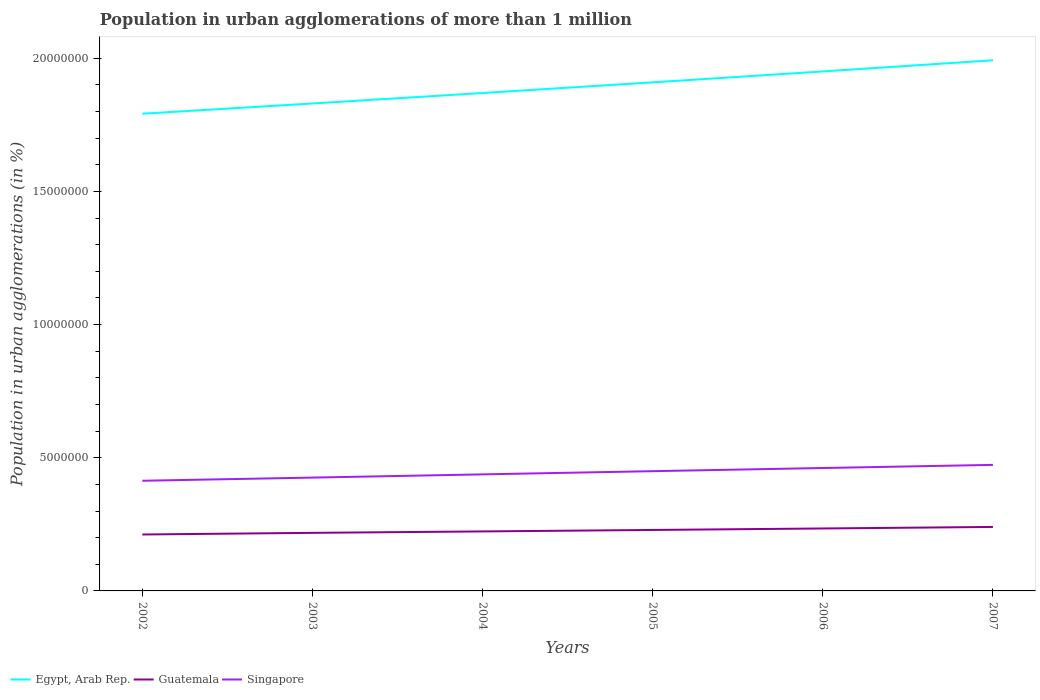How many different coloured lines are there?
Your response must be concise. 3. Is the number of lines equal to the number of legend labels?
Your response must be concise. Yes. Across all years, what is the maximum population in urban agglomerations in Singapore?
Your answer should be compact. 4.14e+06. In which year was the population in urban agglomerations in Guatemala maximum?
Your answer should be very brief. 2002. What is the total population in urban agglomerations in Singapore in the graph?
Keep it short and to the point. -2.39e+05. What is the difference between the highest and the second highest population in urban agglomerations in Egypt, Arab Rep.?
Keep it short and to the point. 2.01e+06. What is the difference between the highest and the lowest population in urban agglomerations in Singapore?
Offer a terse response. 3. Is the population in urban agglomerations in Egypt, Arab Rep. strictly greater than the population in urban agglomerations in Guatemala over the years?
Keep it short and to the point. No. How many lines are there?
Offer a terse response. 3. How many years are there in the graph?
Your answer should be compact. 6. What is the difference between two consecutive major ticks on the Y-axis?
Your answer should be compact. 5.00e+06. Are the values on the major ticks of Y-axis written in scientific E-notation?
Offer a very short reply. No. Does the graph contain grids?
Ensure brevity in your answer.  No. Where does the legend appear in the graph?
Offer a very short reply. Bottom left. What is the title of the graph?
Offer a terse response. Population in urban agglomerations of more than 1 million. What is the label or title of the X-axis?
Give a very brief answer. Years. What is the label or title of the Y-axis?
Provide a short and direct response. Population in urban agglomerations (in %). What is the Population in urban agglomerations (in %) in Egypt, Arab Rep. in 2002?
Your answer should be very brief. 1.79e+07. What is the Population in urban agglomerations (in %) of Guatemala in 2002?
Your response must be concise. 2.12e+06. What is the Population in urban agglomerations (in %) in Singapore in 2002?
Your answer should be compact. 4.14e+06. What is the Population in urban agglomerations (in %) of Egypt, Arab Rep. in 2003?
Keep it short and to the point. 1.83e+07. What is the Population in urban agglomerations (in %) of Guatemala in 2003?
Offer a terse response. 2.18e+06. What is the Population in urban agglomerations (in %) of Singapore in 2003?
Your answer should be very brief. 4.25e+06. What is the Population in urban agglomerations (in %) in Egypt, Arab Rep. in 2004?
Make the answer very short. 1.87e+07. What is the Population in urban agglomerations (in %) of Guatemala in 2004?
Make the answer very short. 2.23e+06. What is the Population in urban agglomerations (in %) in Singapore in 2004?
Ensure brevity in your answer.  4.38e+06. What is the Population in urban agglomerations (in %) of Egypt, Arab Rep. in 2005?
Make the answer very short. 1.91e+07. What is the Population in urban agglomerations (in %) of Guatemala in 2005?
Offer a terse response. 2.29e+06. What is the Population in urban agglomerations (in %) in Singapore in 2005?
Make the answer very short. 4.50e+06. What is the Population in urban agglomerations (in %) of Egypt, Arab Rep. in 2006?
Provide a short and direct response. 1.95e+07. What is the Population in urban agglomerations (in %) in Guatemala in 2006?
Make the answer very short. 2.34e+06. What is the Population in urban agglomerations (in %) of Singapore in 2006?
Offer a terse response. 4.61e+06. What is the Population in urban agglomerations (in %) of Egypt, Arab Rep. in 2007?
Provide a succinct answer. 1.99e+07. What is the Population in urban agglomerations (in %) of Guatemala in 2007?
Offer a very short reply. 2.40e+06. What is the Population in urban agglomerations (in %) in Singapore in 2007?
Provide a short and direct response. 4.73e+06. Across all years, what is the maximum Population in urban agglomerations (in %) of Egypt, Arab Rep.?
Ensure brevity in your answer.  1.99e+07. Across all years, what is the maximum Population in urban agglomerations (in %) of Guatemala?
Ensure brevity in your answer.  2.40e+06. Across all years, what is the maximum Population in urban agglomerations (in %) of Singapore?
Offer a terse response. 4.73e+06. Across all years, what is the minimum Population in urban agglomerations (in %) in Egypt, Arab Rep.?
Provide a short and direct response. 1.79e+07. Across all years, what is the minimum Population in urban agglomerations (in %) in Guatemala?
Make the answer very short. 2.12e+06. Across all years, what is the minimum Population in urban agglomerations (in %) in Singapore?
Provide a short and direct response. 4.14e+06. What is the total Population in urban agglomerations (in %) of Egypt, Arab Rep. in the graph?
Give a very brief answer. 1.13e+08. What is the total Population in urban agglomerations (in %) of Guatemala in the graph?
Your answer should be very brief. 1.36e+07. What is the total Population in urban agglomerations (in %) in Singapore in the graph?
Ensure brevity in your answer.  2.66e+07. What is the difference between the Population in urban agglomerations (in %) of Egypt, Arab Rep. in 2002 and that in 2003?
Give a very brief answer. -3.84e+05. What is the difference between the Population in urban agglomerations (in %) in Guatemala in 2002 and that in 2003?
Give a very brief answer. -6.19e+04. What is the difference between the Population in urban agglomerations (in %) of Singapore in 2002 and that in 2003?
Your answer should be compact. -1.19e+05. What is the difference between the Population in urban agglomerations (in %) in Egypt, Arab Rep. in 2002 and that in 2004?
Your answer should be very brief. -7.78e+05. What is the difference between the Population in urban agglomerations (in %) of Guatemala in 2002 and that in 2004?
Offer a very short reply. -1.15e+05. What is the difference between the Population in urban agglomerations (in %) of Singapore in 2002 and that in 2004?
Offer a very short reply. -2.39e+05. What is the difference between the Population in urban agglomerations (in %) in Egypt, Arab Rep. in 2002 and that in 2005?
Ensure brevity in your answer.  -1.18e+06. What is the difference between the Population in urban agglomerations (in %) in Guatemala in 2002 and that in 2005?
Your response must be concise. -1.70e+05. What is the difference between the Population in urban agglomerations (in %) in Singapore in 2002 and that in 2005?
Offer a terse response. -3.59e+05. What is the difference between the Population in urban agglomerations (in %) of Egypt, Arab Rep. in 2002 and that in 2006?
Give a very brief answer. -1.59e+06. What is the difference between the Population in urban agglomerations (in %) of Guatemala in 2002 and that in 2006?
Keep it short and to the point. -2.26e+05. What is the difference between the Population in urban agglomerations (in %) of Singapore in 2002 and that in 2006?
Offer a very short reply. -4.78e+05. What is the difference between the Population in urban agglomerations (in %) of Egypt, Arab Rep. in 2002 and that in 2007?
Offer a terse response. -2.01e+06. What is the difference between the Population in urban agglomerations (in %) of Guatemala in 2002 and that in 2007?
Your response must be concise. -2.84e+05. What is the difference between the Population in urban agglomerations (in %) in Singapore in 2002 and that in 2007?
Keep it short and to the point. -5.96e+05. What is the difference between the Population in urban agglomerations (in %) in Egypt, Arab Rep. in 2003 and that in 2004?
Keep it short and to the point. -3.93e+05. What is the difference between the Population in urban agglomerations (in %) in Guatemala in 2003 and that in 2004?
Ensure brevity in your answer.  -5.36e+04. What is the difference between the Population in urban agglomerations (in %) of Singapore in 2003 and that in 2004?
Your answer should be compact. -1.21e+05. What is the difference between the Population in urban agglomerations (in %) in Egypt, Arab Rep. in 2003 and that in 2005?
Keep it short and to the point. -7.94e+05. What is the difference between the Population in urban agglomerations (in %) in Guatemala in 2003 and that in 2005?
Your answer should be very brief. -1.08e+05. What is the difference between the Population in urban agglomerations (in %) in Singapore in 2003 and that in 2005?
Ensure brevity in your answer.  -2.41e+05. What is the difference between the Population in urban agglomerations (in %) in Egypt, Arab Rep. in 2003 and that in 2006?
Provide a succinct answer. -1.20e+06. What is the difference between the Population in urban agglomerations (in %) in Guatemala in 2003 and that in 2006?
Your answer should be compact. -1.64e+05. What is the difference between the Population in urban agglomerations (in %) in Singapore in 2003 and that in 2006?
Give a very brief answer. -3.60e+05. What is the difference between the Population in urban agglomerations (in %) of Egypt, Arab Rep. in 2003 and that in 2007?
Your answer should be very brief. -1.62e+06. What is the difference between the Population in urban agglomerations (in %) in Guatemala in 2003 and that in 2007?
Provide a succinct answer. -2.22e+05. What is the difference between the Population in urban agglomerations (in %) in Singapore in 2003 and that in 2007?
Offer a terse response. -4.77e+05. What is the difference between the Population in urban agglomerations (in %) of Egypt, Arab Rep. in 2004 and that in 2005?
Your response must be concise. -4.01e+05. What is the difference between the Population in urban agglomerations (in %) in Guatemala in 2004 and that in 2005?
Your answer should be very brief. -5.47e+04. What is the difference between the Population in urban agglomerations (in %) in Singapore in 2004 and that in 2005?
Provide a short and direct response. -1.20e+05. What is the difference between the Population in urban agglomerations (in %) of Egypt, Arab Rep. in 2004 and that in 2006?
Your response must be concise. -8.10e+05. What is the difference between the Population in urban agglomerations (in %) in Guatemala in 2004 and that in 2006?
Your response must be concise. -1.11e+05. What is the difference between the Population in urban agglomerations (in %) in Singapore in 2004 and that in 2006?
Offer a terse response. -2.39e+05. What is the difference between the Population in urban agglomerations (in %) in Egypt, Arab Rep. in 2004 and that in 2007?
Offer a very short reply. -1.23e+06. What is the difference between the Population in urban agglomerations (in %) in Guatemala in 2004 and that in 2007?
Your response must be concise. -1.68e+05. What is the difference between the Population in urban agglomerations (in %) of Singapore in 2004 and that in 2007?
Your response must be concise. -3.57e+05. What is the difference between the Population in urban agglomerations (in %) of Egypt, Arab Rep. in 2005 and that in 2006?
Offer a terse response. -4.10e+05. What is the difference between the Population in urban agglomerations (in %) of Guatemala in 2005 and that in 2006?
Give a very brief answer. -5.62e+04. What is the difference between the Population in urban agglomerations (in %) in Singapore in 2005 and that in 2006?
Make the answer very short. -1.19e+05. What is the difference between the Population in urban agglomerations (in %) of Egypt, Arab Rep. in 2005 and that in 2007?
Offer a very short reply. -8.28e+05. What is the difference between the Population in urban agglomerations (in %) in Guatemala in 2005 and that in 2007?
Make the answer very short. -1.14e+05. What is the difference between the Population in urban agglomerations (in %) of Singapore in 2005 and that in 2007?
Offer a terse response. -2.37e+05. What is the difference between the Population in urban agglomerations (in %) of Egypt, Arab Rep. in 2006 and that in 2007?
Provide a short and direct response. -4.18e+05. What is the difference between the Population in urban agglomerations (in %) in Guatemala in 2006 and that in 2007?
Provide a succinct answer. -5.75e+04. What is the difference between the Population in urban agglomerations (in %) in Singapore in 2006 and that in 2007?
Keep it short and to the point. -1.18e+05. What is the difference between the Population in urban agglomerations (in %) of Egypt, Arab Rep. in 2002 and the Population in urban agglomerations (in %) of Guatemala in 2003?
Give a very brief answer. 1.57e+07. What is the difference between the Population in urban agglomerations (in %) in Egypt, Arab Rep. in 2002 and the Population in urban agglomerations (in %) in Singapore in 2003?
Offer a very short reply. 1.37e+07. What is the difference between the Population in urban agglomerations (in %) of Guatemala in 2002 and the Population in urban agglomerations (in %) of Singapore in 2003?
Provide a short and direct response. -2.14e+06. What is the difference between the Population in urban agglomerations (in %) in Egypt, Arab Rep. in 2002 and the Population in urban agglomerations (in %) in Guatemala in 2004?
Keep it short and to the point. 1.57e+07. What is the difference between the Population in urban agglomerations (in %) in Egypt, Arab Rep. in 2002 and the Population in urban agglomerations (in %) in Singapore in 2004?
Provide a succinct answer. 1.35e+07. What is the difference between the Population in urban agglomerations (in %) in Guatemala in 2002 and the Population in urban agglomerations (in %) in Singapore in 2004?
Offer a terse response. -2.26e+06. What is the difference between the Population in urban agglomerations (in %) in Egypt, Arab Rep. in 2002 and the Population in urban agglomerations (in %) in Guatemala in 2005?
Your answer should be very brief. 1.56e+07. What is the difference between the Population in urban agglomerations (in %) in Egypt, Arab Rep. in 2002 and the Population in urban agglomerations (in %) in Singapore in 2005?
Ensure brevity in your answer.  1.34e+07. What is the difference between the Population in urban agglomerations (in %) of Guatemala in 2002 and the Population in urban agglomerations (in %) of Singapore in 2005?
Keep it short and to the point. -2.38e+06. What is the difference between the Population in urban agglomerations (in %) of Egypt, Arab Rep. in 2002 and the Population in urban agglomerations (in %) of Guatemala in 2006?
Offer a terse response. 1.56e+07. What is the difference between the Population in urban agglomerations (in %) in Egypt, Arab Rep. in 2002 and the Population in urban agglomerations (in %) in Singapore in 2006?
Provide a succinct answer. 1.33e+07. What is the difference between the Population in urban agglomerations (in %) in Guatemala in 2002 and the Population in urban agglomerations (in %) in Singapore in 2006?
Provide a succinct answer. -2.50e+06. What is the difference between the Population in urban agglomerations (in %) in Egypt, Arab Rep. in 2002 and the Population in urban agglomerations (in %) in Guatemala in 2007?
Provide a succinct answer. 1.55e+07. What is the difference between the Population in urban agglomerations (in %) of Egypt, Arab Rep. in 2002 and the Population in urban agglomerations (in %) of Singapore in 2007?
Offer a very short reply. 1.32e+07. What is the difference between the Population in urban agglomerations (in %) of Guatemala in 2002 and the Population in urban agglomerations (in %) of Singapore in 2007?
Offer a terse response. -2.61e+06. What is the difference between the Population in urban agglomerations (in %) in Egypt, Arab Rep. in 2003 and the Population in urban agglomerations (in %) in Guatemala in 2004?
Your answer should be compact. 1.61e+07. What is the difference between the Population in urban agglomerations (in %) in Egypt, Arab Rep. in 2003 and the Population in urban agglomerations (in %) in Singapore in 2004?
Ensure brevity in your answer.  1.39e+07. What is the difference between the Population in urban agglomerations (in %) in Guatemala in 2003 and the Population in urban agglomerations (in %) in Singapore in 2004?
Provide a short and direct response. -2.19e+06. What is the difference between the Population in urban agglomerations (in %) in Egypt, Arab Rep. in 2003 and the Population in urban agglomerations (in %) in Guatemala in 2005?
Keep it short and to the point. 1.60e+07. What is the difference between the Population in urban agglomerations (in %) of Egypt, Arab Rep. in 2003 and the Population in urban agglomerations (in %) of Singapore in 2005?
Keep it short and to the point. 1.38e+07. What is the difference between the Population in urban agglomerations (in %) in Guatemala in 2003 and the Population in urban agglomerations (in %) in Singapore in 2005?
Your answer should be very brief. -2.32e+06. What is the difference between the Population in urban agglomerations (in %) of Egypt, Arab Rep. in 2003 and the Population in urban agglomerations (in %) of Guatemala in 2006?
Provide a short and direct response. 1.60e+07. What is the difference between the Population in urban agglomerations (in %) in Egypt, Arab Rep. in 2003 and the Population in urban agglomerations (in %) in Singapore in 2006?
Your answer should be very brief. 1.37e+07. What is the difference between the Population in urban agglomerations (in %) of Guatemala in 2003 and the Population in urban agglomerations (in %) of Singapore in 2006?
Provide a short and direct response. -2.43e+06. What is the difference between the Population in urban agglomerations (in %) in Egypt, Arab Rep. in 2003 and the Population in urban agglomerations (in %) in Guatemala in 2007?
Provide a succinct answer. 1.59e+07. What is the difference between the Population in urban agglomerations (in %) in Egypt, Arab Rep. in 2003 and the Population in urban agglomerations (in %) in Singapore in 2007?
Offer a very short reply. 1.36e+07. What is the difference between the Population in urban agglomerations (in %) in Guatemala in 2003 and the Population in urban agglomerations (in %) in Singapore in 2007?
Give a very brief answer. -2.55e+06. What is the difference between the Population in urban agglomerations (in %) in Egypt, Arab Rep. in 2004 and the Population in urban agglomerations (in %) in Guatemala in 2005?
Offer a very short reply. 1.64e+07. What is the difference between the Population in urban agglomerations (in %) in Egypt, Arab Rep. in 2004 and the Population in urban agglomerations (in %) in Singapore in 2005?
Ensure brevity in your answer.  1.42e+07. What is the difference between the Population in urban agglomerations (in %) of Guatemala in 2004 and the Population in urban agglomerations (in %) of Singapore in 2005?
Your answer should be very brief. -2.26e+06. What is the difference between the Population in urban agglomerations (in %) in Egypt, Arab Rep. in 2004 and the Population in urban agglomerations (in %) in Guatemala in 2006?
Offer a terse response. 1.63e+07. What is the difference between the Population in urban agglomerations (in %) of Egypt, Arab Rep. in 2004 and the Population in urban agglomerations (in %) of Singapore in 2006?
Ensure brevity in your answer.  1.41e+07. What is the difference between the Population in urban agglomerations (in %) in Guatemala in 2004 and the Population in urban agglomerations (in %) in Singapore in 2006?
Keep it short and to the point. -2.38e+06. What is the difference between the Population in urban agglomerations (in %) in Egypt, Arab Rep. in 2004 and the Population in urban agglomerations (in %) in Guatemala in 2007?
Your response must be concise. 1.63e+07. What is the difference between the Population in urban agglomerations (in %) in Egypt, Arab Rep. in 2004 and the Population in urban agglomerations (in %) in Singapore in 2007?
Offer a very short reply. 1.40e+07. What is the difference between the Population in urban agglomerations (in %) of Guatemala in 2004 and the Population in urban agglomerations (in %) of Singapore in 2007?
Offer a very short reply. -2.50e+06. What is the difference between the Population in urban agglomerations (in %) in Egypt, Arab Rep. in 2005 and the Population in urban agglomerations (in %) in Guatemala in 2006?
Your response must be concise. 1.67e+07. What is the difference between the Population in urban agglomerations (in %) in Egypt, Arab Rep. in 2005 and the Population in urban agglomerations (in %) in Singapore in 2006?
Keep it short and to the point. 1.45e+07. What is the difference between the Population in urban agglomerations (in %) of Guatemala in 2005 and the Population in urban agglomerations (in %) of Singapore in 2006?
Give a very brief answer. -2.33e+06. What is the difference between the Population in urban agglomerations (in %) of Egypt, Arab Rep. in 2005 and the Population in urban agglomerations (in %) of Guatemala in 2007?
Provide a succinct answer. 1.67e+07. What is the difference between the Population in urban agglomerations (in %) of Egypt, Arab Rep. in 2005 and the Population in urban agglomerations (in %) of Singapore in 2007?
Offer a very short reply. 1.44e+07. What is the difference between the Population in urban agglomerations (in %) of Guatemala in 2005 and the Population in urban agglomerations (in %) of Singapore in 2007?
Your answer should be compact. -2.44e+06. What is the difference between the Population in urban agglomerations (in %) in Egypt, Arab Rep. in 2006 and the Population in urban agglomerations (in %) in Guatemala in 2007?
Your answer should be compact. 1.71e+07. What is the difference between the Population in urban agglomerations (in %) in Egypt, Arab Rep. in 2006 and the Population in urban agglomerations (in %) in Singapore in 2007?
Keep it short and to the point. 1.48e+07. What is the difference between the Population in urban agglomerations (in %) of Guatemala in 2006 and the Population in urban agglomerations (in %) of Singapore in 2007?
Keep it short and to the point. -2.39e+06. What is the average Population in urban agglomerations (in %) of Egypt, Arab Rep. per year?
Make the answer very short. 1.89e+07. What is the average Population in urban agglomerations (in %) in Guatemala per year?
Make the answer very short. 2.26e+06. What is the average Population in urban agglomerations (in %) in Singapore per year?
Provide a short and direct response. 4.43e+06. In the year 2002, what is the difference between the Population in urban agglomerations (in %) in Egypt, Arab Rep. and Population in urban agglomerations (in %) in Guatemala?
Provide a short and direct response. 1.58e+07. In the year 2002, what is the difference between the Population in urban agglomerations (in %) in Egypt, Arab Rep. and Population in urban agglomerations (in %) in Singapore?
Offer a terse response. 1.38e+07. In the year 2002, what is the difference between the Population in urban agglomerations (in %) of Guatemala and Population in urban agglomerations (in %) of Singapore?
Make the answer very short. -2.02e+06. In the year 2003, what is the difference between the Population in urban agglomerations (in %) of Egypt, Arab Rep. and Population in urban agglomerations (in %) of Guatemala?
Keep it short and to the point. 1.61e+07. In the year 2003, what is the difference between the Population in urban agglomerations (in %) in Egypt, Arab Rep. and Population in urban agglomerations (in %) in Singapore?
Offer a very short reply. 1.40e+07. In the year 2003, what is the difference between the Population in urban agglomerations (in %) of Guatemala and Population in urban agglomerations (in %) of Singapore?
Your response must be concise. -2.07e+06. In the year 2004, what is the difference between the Population in urban agglomerations (in %) in Egypt, Arab Rep. and Population in urban agglomerations (in %) in Guatemala?
Provide a succinct answer. 1.65e+07. In the year 2004, what is the difference between the Population in urban agglomerations (in %) in Egypt, Arab Rep. and Population in urban agglomerations (in %) in Singapore?
Provide a succinct answer. 1.43e+07. In the year 2004, what is the difference between the Population in urban agglomerations (in %) in Guatemala and Population in urban agglomerations (in %) in Singapore?
Provide a short and direct response. -2.14e+06. In the year 2005, what is the difference between the Population in urban agglomerations (in %) of Egypt, Arab Rep. and Population in urban agglomerations (in %) of Guatemala?
Provide a succinct answer. 1.68e+07. In the year 2005, what is the difference between the Population in urban agglomerations (in %) in Egypt, Arab Rep. and Population in urban agglomerations (in %) in Singapore?
Provide a succinct answer. 1.46e+07. In the year 2005, what is the difference between the Population in urban agglomerations (in %) of Guatemala and Population in urban agglomerations (in %) of Singapore?
Provide a short and direct response. -2.21e+06. In the year 2006, what is the difference between the Population in urban agglomerations (in %) of Egypt, Arab Rep. and Population in urban agglomerations (in %) of Guatemala?
Offer a very short reply. 1.72e+07. In the year 2006, what is the difference between the Population in urban agglomerations (in %) of Egypt, Arab Rep. and Population in urban agglomerations (in %) of Singapore?
Offer a terse response. 1.49e+07. In the year 2006, what is the difference between the Population in urban agglomerations (in %) in Guatemala and Population in urban agglomerations (in %) in Singapore?
Keep it short and to the point. -2.27e+06. In the year 2007, what is the difference between the Population in urban agglomerations (in %) of Egypt, Arab Rep. and Population in urban agglomerations (in %) of Guatemala?
Your response must be concise. 1.75e+07. In the year 2007, what is the difference between the Population in urban agglomerations (in %) of Egypt, Arab Rep. and Population in urban agglomerations (in %) of Singapore?
Offer a very short reply. 1.52e+07. In the year 2007, what is the difference between the Population in urban agglomerations (in %) in Guatemala and Population in urban agglomerations (in %) in Singapore?
Provide a short and direct response. -2.33e+06. What is the ratio of the Population in urban agglomerations (in %) in Egypt, Arab Rep. in 2002 to that in 2003?
Provide a succinct answer. 0.98. What is the ratio of the Population in urban agglomerations (in %) of Guatemala in 2002 to that in 2003?
Offer a terse response. 0.97. What is the ratio of the Population in urban agglomerations (in %) of Singapore in 2002 to that in 2003?
Provide a short and direct response. 0.97. What is the ratio of the Population in urban agglomerations (in %) in Egypt, Arab Rep. in 2002 to that in 2004?
Provide a short and direct response. 0.96. What is the ratio of the Population in urban agglomerations (in %) of Guatemala in 2002 to that in 2004?
Keep it short and to the point. 0.95. What is the ratio of the Population in urban agglomerations (in %) of Singapore in 2002 to that in 2004?
Keep it short and to the point. 0.95. What is the ratio of the Population in urban agglomerations (in %) in Egypt, Arab Rep. in 2002 to that in 2005?
Offer a very short reply. 0.94. What is the ratio of the Population in urban agglomerations (in %) of Guatemala in 2002 to that in 2005?
Your answer should be compact. 0.93. What is the ratio of the Population in urban agglomerations (in %) in Singapore in 2002 to that in 2005?
Offer a terse response. 0.92. What is the ratio of the Population in urban agglomerations (in %) of Egypt, Arab Rep. in 2002 to that in 2006?
Give a very brief answer. 0.92. What is the ratio of the Population in urban agglomerations (in %) of Guatemala in 2002 to that in 2006?
Provide a succinct answer. 0.9. What is the ratio of the Population in urban agglomerations (in %) of Singapore in 2002 to that in 2006?
Your answer should be very brief. 0.9. What is the ratio of the Population in urban agglomerations (in %) in Egypt, Arab Rep. in 2002 to that in 2007?
Give a very brief answer. 0.9. What is the ratio of the Population in urban agglomerations (in %) of Guatemala in 2002 to that in 2007?
Your answer should be very brief. 0.88. What is the ratio of the Population in urban agglomerations (in %) in Singapore in 2002 to that in 2007?
Your answer should be compact. 0.87. What is the ratio of the Population in urban agglomerations (in %) of Guatemala in 2003 to that in 2004?
Keep it short and to the point. 0.98. What is the ratio of the Population in urban agglomerations (in %) in Singapore in 2003 to that in 2004?
Keep it short and to the point. 0.97. What is the ratio of the Population in urban agglomerations (in %) in Egypt, Arab Rep. in 2003 to that in 2005?
Your response must be concise. 0.96. What is the ratio of the Population in urban agglomerations (in %) of Guatemala in 2003 to that in 2005?
Make the answer very short. 0.95. What is the ratio of the Population in urban agglomerations (in %) of Singapore in 2003 to that in 2005?
Your response must be concise. 0.95. What is the ratio of the Population in urban agglomerations (in %) in Egypt, Arab Rep. in 2003 to that in 2006?
Make the answer very short. 0.94. What is the ratio of the Population in urban agglomerations (in %) in Guatemala in 2003 to that in 2006?
Your response must be concise. 0.93. What is the ratio of the Population in urban agglomerations (in %) in Singapore in 2003 to that in 2006?
Your answer should be compact. 0.92. What is the ratio of the Population in urban agglomerations (in %) of Egypt, Arab Rep. in 2003 to that in 2007?
Keep it short and to the point. 0.92. What is the ratio of the Population in urban agglomerations (in %) in Guatemala in 2003 to that in 2007?
Your answer should be very brief. 0.91. What is the ratio of the Population in urban agglomerations (in %) of Singapore in 2003 to that in 2007?
Keep it short and to the point. 0.9. What is the ratio of the Population in urban agglomerations (in %) of Egypt, Arab Rep. in 2004 to that in 2005?
Offer a terse response. 0.98. What is the ratio of the Population in urban agglomerations (in %) of Guatemala in 2004 to that in 2005?
Make the answer very short. 0.98. What is the ratio of the Population in urban agglomerations (in %) in Singapore in 2004 to that in 2005?
Ensure brevity in your answer.  0.97. What is the ratio of the Population in urban agglomerations (in %) in Egypt, Arab Rep. in 2004 to that in 2006?
Offer a terse response. 0.96. What is the ratio of the Population in urban agglomerations (in %) of Guatemala in 2004 to that in 2006?
Give a very brief answer. 0.95. What is the ratio of the Population in urban agglomerations (in %) of Singapore in 2004 to that in 2006?
Offer a terse response. 0.95. What is the ratio of the Population in urban agglomerations (in %) of Egypt, Arab Rep. in 2004 to that in 2007?
Your answer should be compact. 0.94. What is the ratio of the Population in urban agglomerations (in %) of Guatemala in 2004 to that in 2007?
Give a very brief answer. 0.93. What is the ratio of the Population in urban agglomerations (in %) in Singapore in 2004 to that in 2007?
Offer a very short reply. 0.92. What is the ratio of the Population in urban agglomerations (in %) in Guatemala in 2005 to that in 2006?
Give a very brief answer. 0.98. What is the ratio of the Population in urban agglomerations (in %) in Singapore in 2005 to that in 2006?
Provide a succinct answer. 0.97. What is the ratio of the Population in urban agglomerations (in %) in Egypt, Arab Rep. in 2005 to that in 2007?
Ensure brevity in your answer.  0.96. What is the ratio of the Population in urban agglomerations (in %) in Guatemala in 2005 to that in 2007?
Ensure brevity in your answer.  0.95. What is the ratio of the Population in urban agglomerations (in %) in Singapore in 2005 to that in 2007?
Provide a short and direct response. 0.95. What is the ratio of the Population in urban agglomerations (in %) of Egypt, Arab Rep. in 2006 to that in 2007?
Provide a short and direct response. 0.98. What is the ratio of the Population in urban agglomerations (in %) in Guatemala in 2006 to that in 2007?
Offer a terse response. 0.98. What is the ratio of the Population in urban agglomerations (in %) of Singapore in 2006 to that in 2007?
Make the answer very short. 0.98. What is the difference between the highest and the second highest Population in urban agglomerations (in %) in Egypt, Arab Rep.?
Your response must be concise. 4.18e+05. What is the difference between the highest and the second highest Population in urban agglomerations (in %) in Guatemala?
Ensure brevity in your answer.  5.75e+04. What is the difference between the highest and the second highest Population in urban agglomerations (in %) in Singapore?
Offer a terse response. 1.18e+05. What is the difference between the highest and the lowest Population in urban agglomerations (in %) in Egypt, Arab Rep.?
Your response must be concise. 2.01e+06. What is the difference between the highest and the lowest Population in urban agglomerations (in %) of Guatemala?
Give a very brief answer. 2.84e+05. What is the difference between the highest and the lowest Population in urban agglomerations (in %) in Singapore?
Keep it short and to the point. 5.96e+05. 